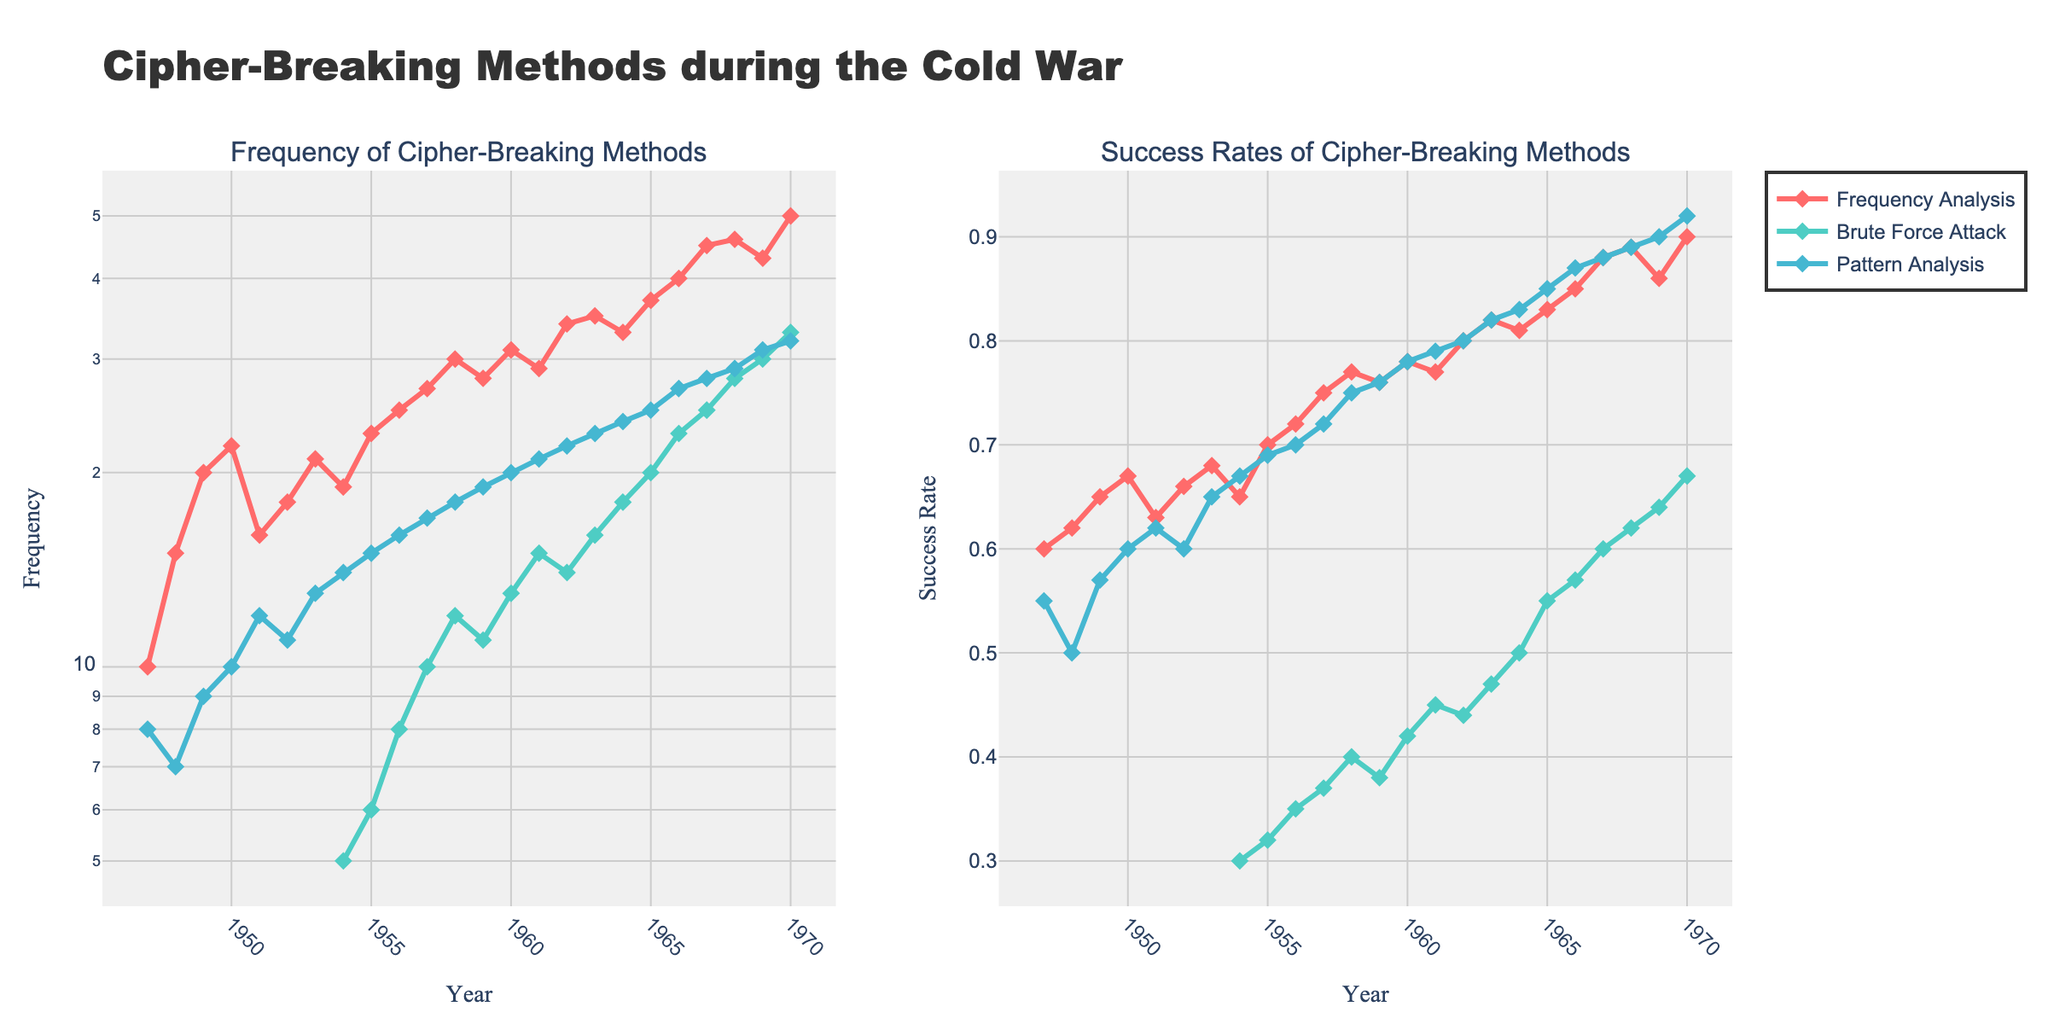What is the title of the figure? The title of the figure is prominently placed at the top and reads "Cipher-Breaking Methods during the Cold War".
Answer: Cipher-Breaking Methods during the Cold War Which cipher-breaking method has the highest frequency in 1970? By looking at the subplot titled "Frequency of Cipher-Breaking Methods," you can see that the method with the highest frequency in 1970 is marked with the largest data point on the y-axis corresponding to 50. This point belongs to "Frequency Analysis".
Answer: Frequency Analysis What was the success rate of "Pattern Analysis" in 1965? In the subplot titled "Success Rates of Cipher-Breaking Methods," locate 1965 on the x-axis and find the corresponding y-value for "Pattern Analysis" marked by the color associated with it. The success rate is at 0.85.
Answer: 0.85 How did the frequency of "Brute Force Attack" change from 1959 to 1960? In the subplot titled "Frequency of Cipher-Breaking Methods", locate the points for "Brute Force Attack" in 1959 and 1960. In 1959, the frequency was 11, and in 1960, it was 13. Therefore, it increased by 2.
Answer: Increased by 2 Which cipher-breaking method shows the highest success rate in 1970? In the subplot titled "Success Rates of Cipher-Breaking Methods," find the data points corresponding to 1970 for all methods. The highest y-value is for "Pattern Analysis" at 0.92.
Answer: Pattern Analysis What is the average success rate of "Frequency Analysis" from 1947 to 1970? Sum all the success rates of "Frequency Analysis" from 1947 to 1970 and divide by the number of years. The sum is 1603 and there are 24 years, so the average is 1603 / 24 = 0.667.
Answer: 0.667 Compare the frequency of "Frequency Analysis" and "Pattern Analysis" in 1956. Which one is higher? In the subplot titled "Frequency of Cipher-Breaking Methods," find the points for 1956 for both methods. "Frequency Analysis" has a frequency of 25, while "Pattern Analysis" has a frequency of 16. Therefore, "Frequency Analysis" is higher.
Answer: Frequency Analysis Did the success rate of "Brute Force Attack" ever surpass 0.6? Check the subplot titled "Success Rates of Cipher-Breaking Methods" for the data points corresponding to "Brute Force Attack". The highest value is 0.67 in 1970, which surpasses 0.6.
Answer: Yes In which year did "Frequency Analysis" first exceed a success rate of 0.7? Find the year where the success rate for "Frequency Analysis" first exceeds 0.7 in the subplot titled "Success Rates of Cipher-Breaking Methods." This happens in 1955.
Answer: 1955 